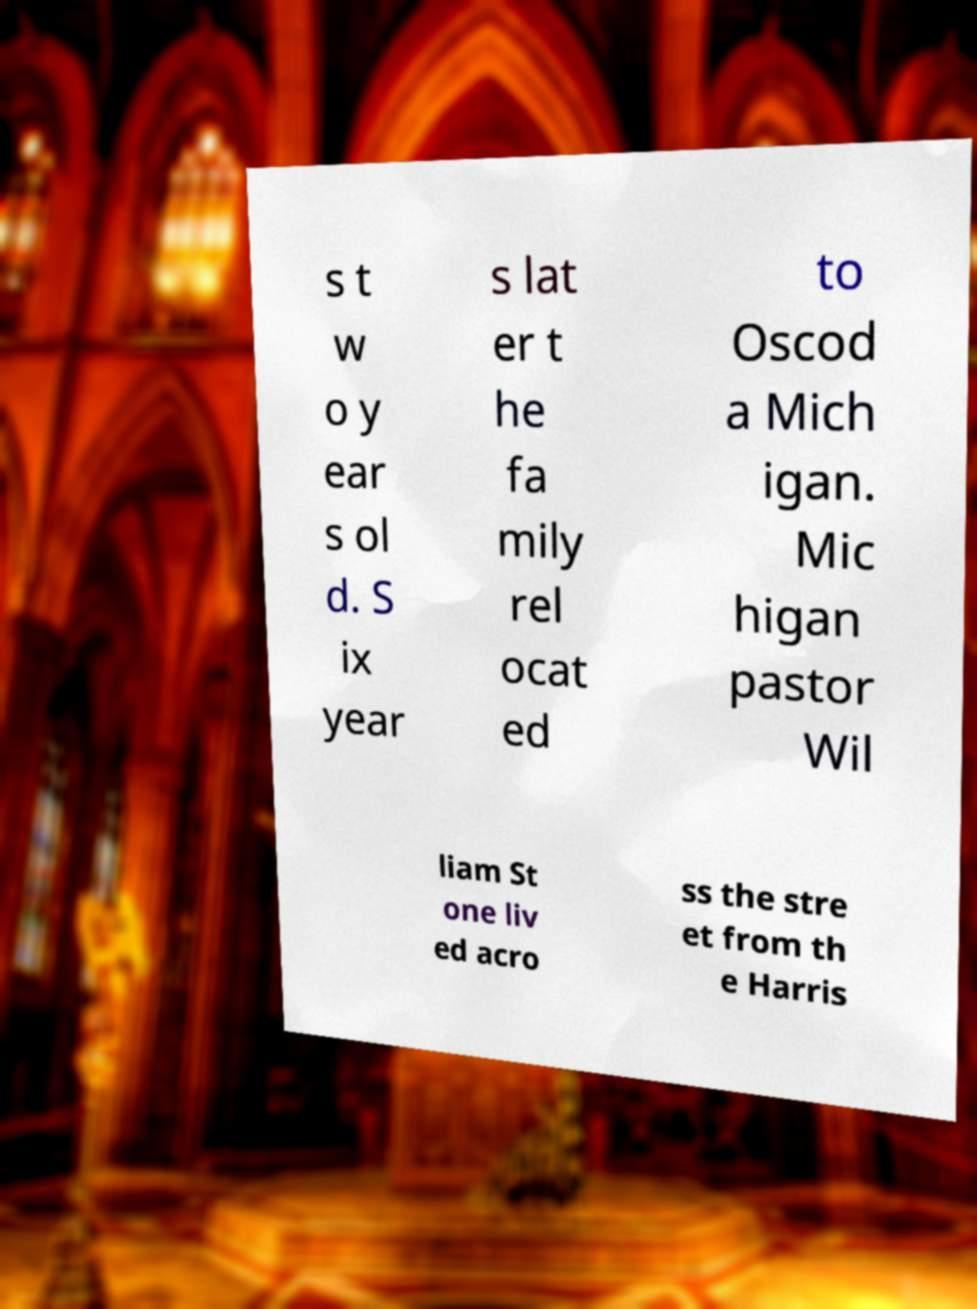I need the written content from this picture converted into text. Can you do that? s t w o y ear s ol d. S ix year s lat er t he fa mily rel ocat ed to Oscod a Mich igan. Mic higan pastor Wil liam St one liv ed acro ss the stre et from th e Harris 